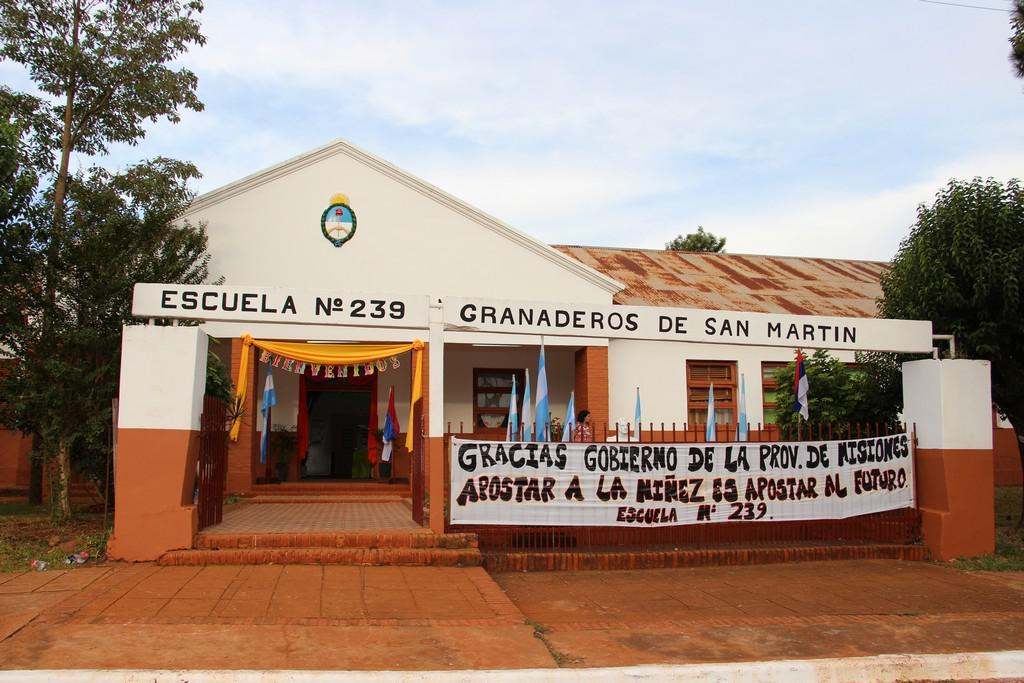What type of structure is visible in the image? There is a building in the image. What decorative elements can be seen on the building? There are flags and an advertisement cloth hanged on the building. What type of cooking equipment is present in the image? There are grills in the image. What is used to identify the location or business in the image? There is a name board in the image. What type of natural elements are present in the image? There are trees in the image. What is visible in the background of the image? The sky is visible in the image, and clouds are present in the sky. Can you tell me how many kitties are playing in the water near the building? There are no kitties present in the image, and therefore no such activity can be observed. 